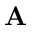Convert formula to latex. <formula><loc_0><loc_0><loc_500><loc_500>A</formula> 